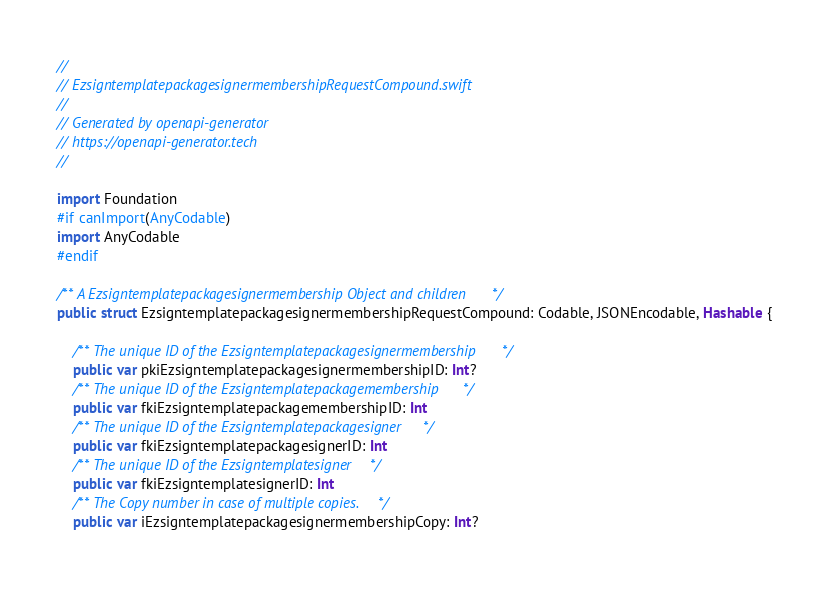Convert code to text. <code><loc_0><loc_0><loc_500><loc_500><_Swift_>//
// EzsigntemplatepackagesignermembershipRequestCompound.swift
//
// Generated by openapi-generator
// https://openapi-generator.tech
//

import Foundation
#if canImport(AnyCodable)
import AnyCodable
#endif

/** A Ezsigntemplatepackagesignermembership Object and children */
public struct EzsigntemplatepackagesignermembershipRequestCompound: Codable, JSONEncodable, Hashable {

    /** The unique ID of the Ezsigntemplatepackagesignermembership */
    public var pkiEzsigntemplatepackagesignermembershipID: Int?
    /** The unique ID of the Ezsigntemplatepackagemembership */
    public var fkiEzsigntemplatepackagemembershipID: Int
    /** The unique ID of the Ezsigntemplatepackagesigner */
    public var fkiEzsigntemplatepackagesignerID: Int
    /** The unique ID of the Ezsigntemplatesigner */
    public var fkiEzsigntemplatesignerID: Int
    /** The Copy number in case of multiple copies. */
    public var iEzsigntemplatepackagesignermembershipCopy: Int?
</code> 